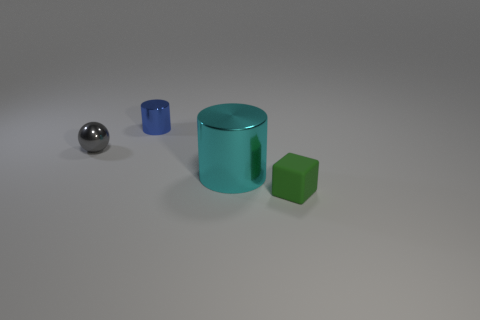Add 1 cyan cylinders. How many objects exist? 5 Subtract all spheres. How many objects are left? 3 Subtract 0 gray blocks. How many objects are left? 4 Subtract all tiny green matte things. Subtract all tiny blue metal cylinders. How many objects are left? 2 Add 3 small gray shiny spheres. How many small gray shiny spheres are left? 4 Add 1 tiny green things. How many tiny green things exist? 2 